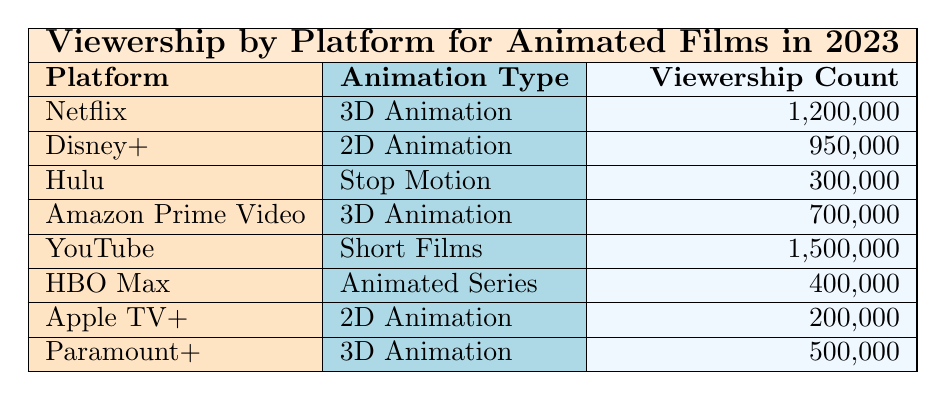What platform has the highest viewership for animated films in 2023? By looking at the viewership count for each platform in the table, YouTube has the highest number at 1,500,000.
Answer: YouTube How many viewership counts are associated with 2D Animation? There are two entries for 2D Animation: one from Disney+ with 950,000 and one from Apple TV+ with 200,000. Adding them together gives 950,000 + 200,000 = 1,150,000.
Answer: 1,150,000 Is there any platform that specializes only in Stop Motion animation? The table lists Hulu as the platform providing Stop Motion animation, and it is the only entry for that animation type.
Answer: Yes What is the total viewership count for all platforms combined? To find the total, we need to sum the viewership counts from each platform: 1,200,000 + 950,000 + 300,000 + 700,000 + 1,500,000 + 400,000 + 200,000 + 500,000 = 5,800,000.
Answer: 5,800,000 Which platform has the least viewership count for animated films? By examining the viewership counts, Apple TV+ has the lowest at 200,000.
Answer: Apple TV+ What is the average viewership for 3D Animation across platforms? 3D Animation appears on three platforms: Netflix (1,200,000), Amazon Prime Video (700,000), and Paramount+ (500,000). First, sum the viewership: 1,200,000 + 700,000 + 500,000 = 2,400,000. Then, divide by three (the number of platforms): 2,400,000 / 3 = 800,000.
Answer: 800,000 Does any platform show both 3D Animation and 2D Animation? The table reveals that no platform provides both types; Netflix and Disney+ provide different types of animation.
Answer: No What is the difference in viewership count between the most and least viewed animation type? The highest is YouTube's Short Films with 1,500,000 and the lowest is Apple TV+’s 2D Animation with 200,000. Calculate the difference: 1,500,000 - 200,000 = 1,300,000.
Answer: 1,300,000 